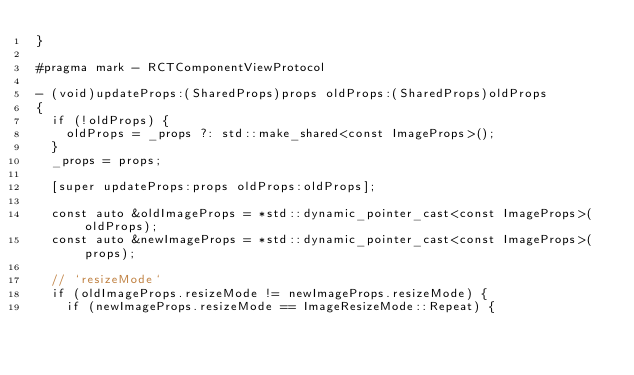<code> <loc_0><loc_0><loc_500><loc_500><_ObjectiveC_>}

#pragma mark - RCTComponentViewProtocol

- (void)updateProps:(SharedProps)props oldProps:(SharedProps)oldProps
{
  if (!oldProps) {
    oldProps = _props ?: std::make_shared<const ImageProps>();
  }
  _props = props;

  [super updateProps:props oldProps:oldProps];

  const auto &oldImageProps = *std::dynamic_pointer_cast<const ImageProps>(oldProps);
  const auto &newImageProps = *std::dynamic_pointer_cast<const ImageProps>(props);

  // `resizeMode`
  if (oldImageProps.resizeMode != newImageProps.resizeMode) {
    if (newImageProps.resizeMode == ImageResizeMode::Repeat) {</code> 